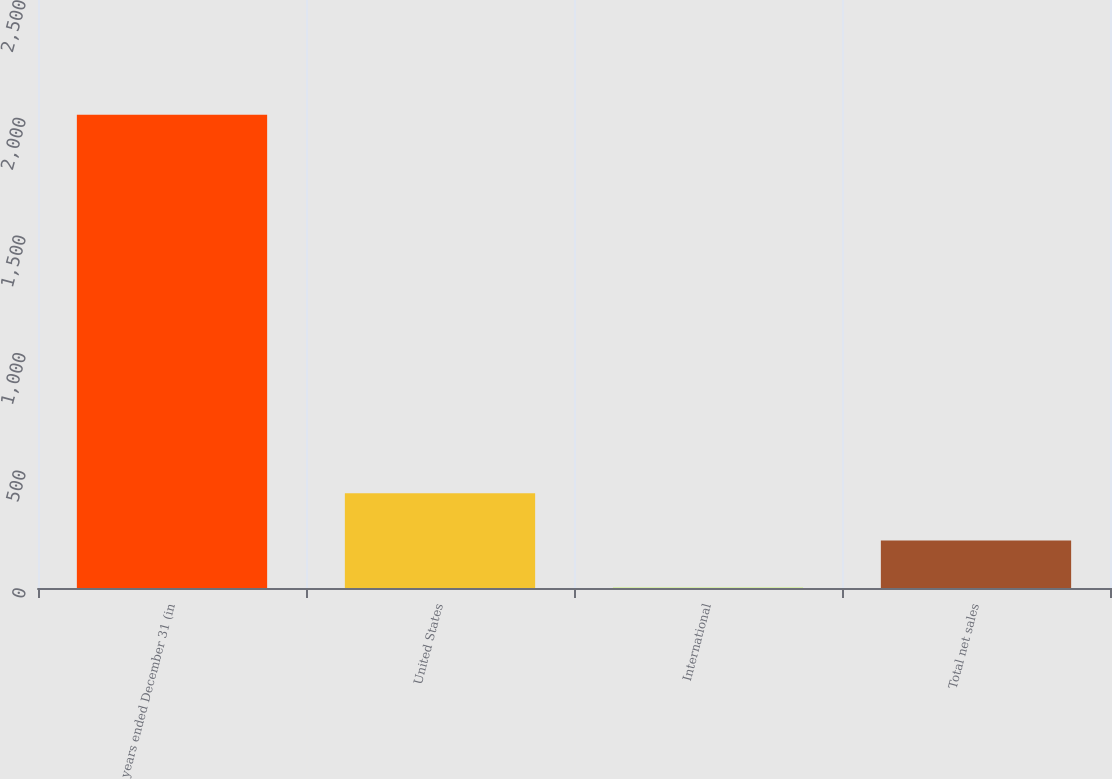Convert chart to OTSL. <chart><loc_0><loc_0><loc_500><loc_500><bar_chart><fcel>years ended December 31 (in<fcel>United States<fcel>International<fcel>Total net sales<nl><fcel>2012<fcel>403.2<fcel>1<fcel>202.1<nl></chart> 